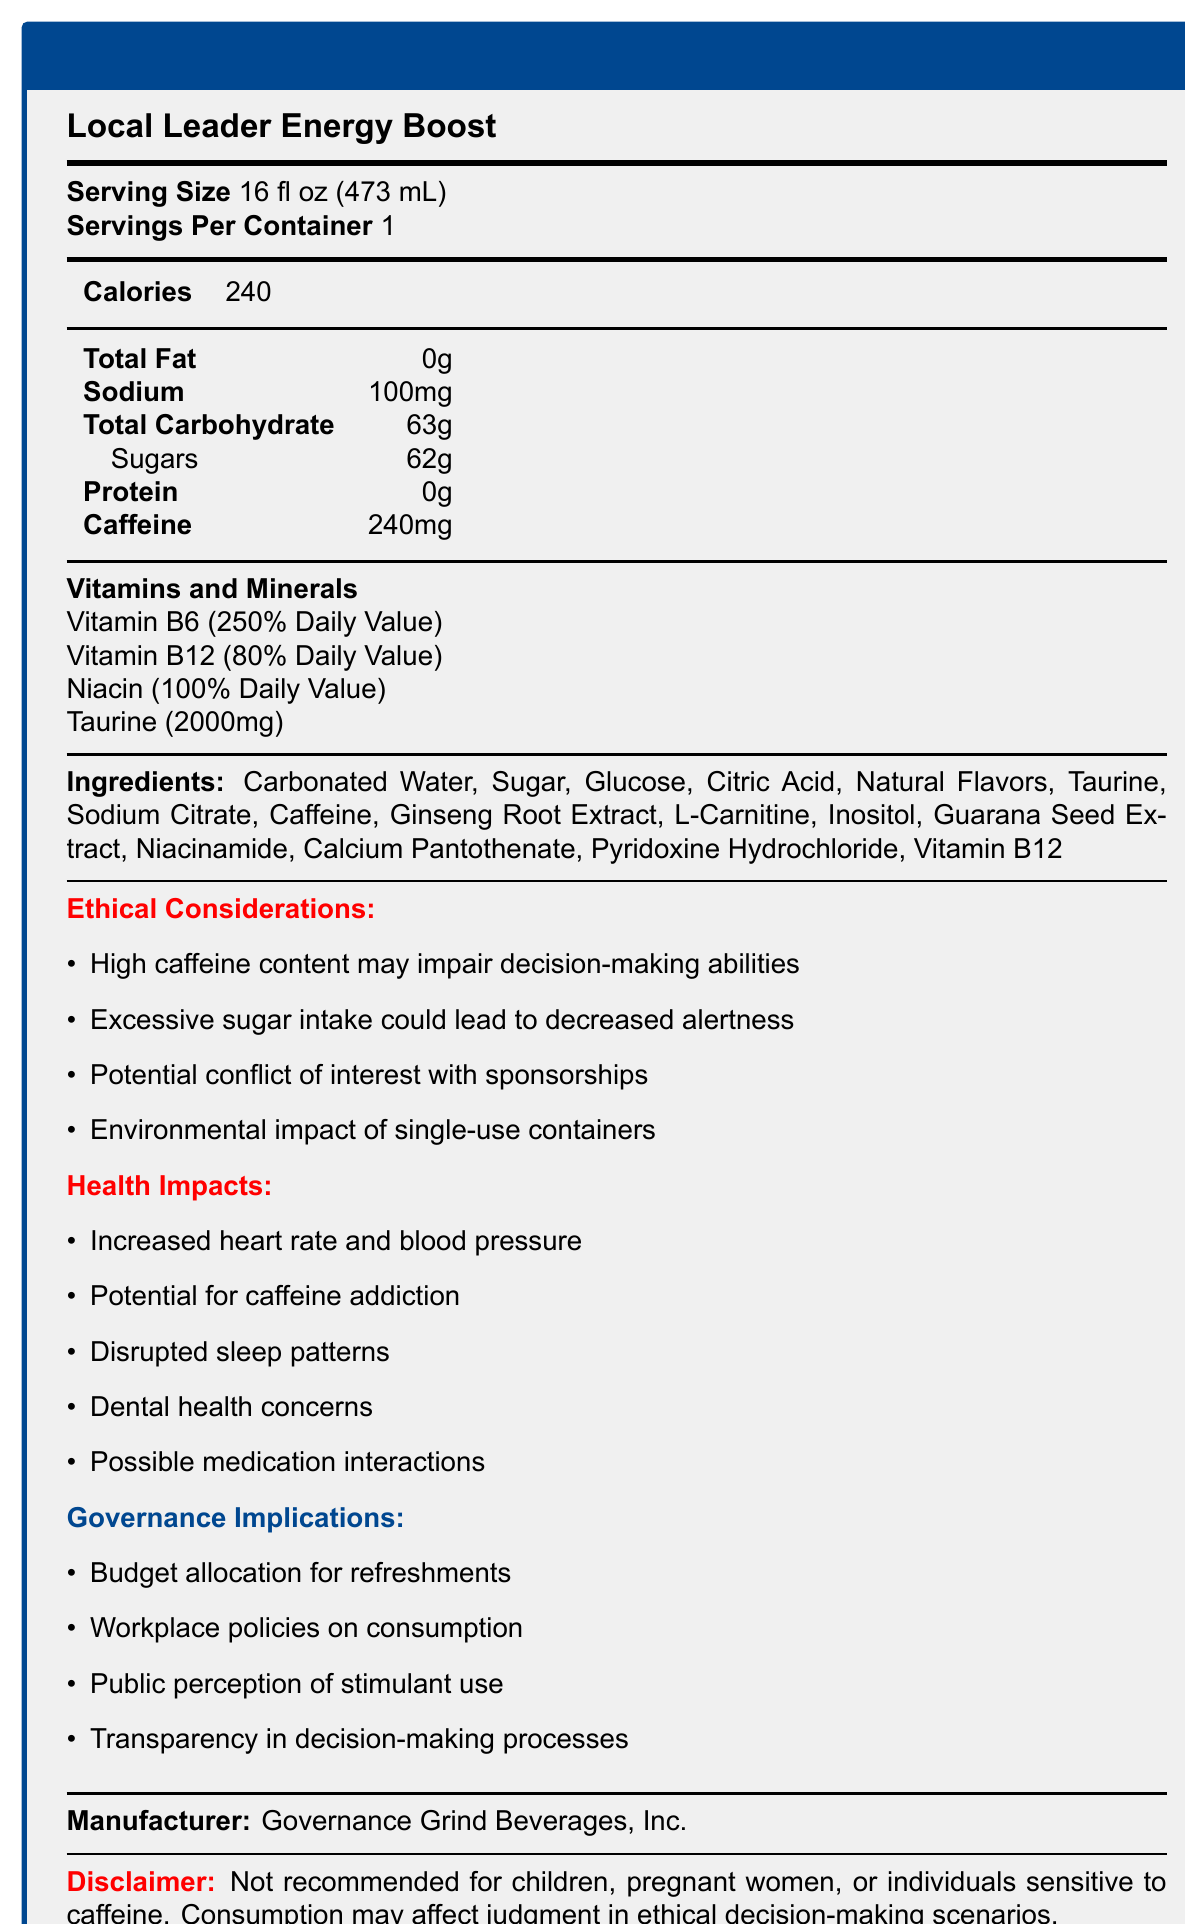what is the serving size of the Local Leader Energy Boost? The document explicitly mentions the serving size as 16 fl oz (473 mL).
Answer: 16 fl oz (473 mL) how much caffeine is present in a single serving of the energy drink? The document lists the caffeine content as 240mg per serving.
Answer: 240mg what is the total carbohydrate content in the Local Leader Energy Boost? The document indicates that the total carbohydrate content is 63g.
Answer: 63g which company manufactures the Local Leader Energy Boost? The manufacturer is mentioned as Governance Grind Beverages, Inc. in the document.
Answer: Governance Grind Beverages, Inc. how many calories are in one serving of the energy drink? The document specifies that one serving of the energy drink contains 240 calories.
Answer: 240 which of the following is NOT listed as an ingredient in the Local Leader Energy Boost? A. Carbonated Water B. High Fructose Corn Syrup C. Ginseng Root Extract D. L-Carnitine The list of ingredients provided in the document does not include High Fructose Corn Syrup.
Answer: B what percentage of the daily value is provided by Vitamin B6 in the energy drink? A. 60% B. 80% C. 100% D. 250% The document states that Vitamin B6 provides 250% of the daily value.
Answer: D are there ethical considerations mentioned regarding the high caffeine content in the energy drink? The document highlights that the high caffeine content may impair decision-making abilities, which is listed under ethical considerations.
Answer: Yes describe the main idea of the document. This summary encompasses all sections of the document, detailing what it covers comprehensively.
Answer: The document provides the Nutrition Facts for a popular energy drink called Local Leader Energy Boost, including information on its serving size, calorie content, ingredients, vitamins, and minerals. It also outlines ethical considerations, potential health impacts, governance implications, and a disclaimer. is the Local Leader Energy Boost recommended for children? The disclaimer in the document explicitly states that the product is not recommended for children.
Answer: No what is the total sugar content in one serving of the energy drink? The document indicates that there are 62g of sugars in one serving.
Answer: 62g can you determine the environmental impact of producing the Local Leader Energy Boost based on the document? While the document mentions the environmental impact of single-use aluminum cans, it does not provide specific details on the overall environmental impact. Therefore, it cannot be fully determined from the given information.
Answer: No 